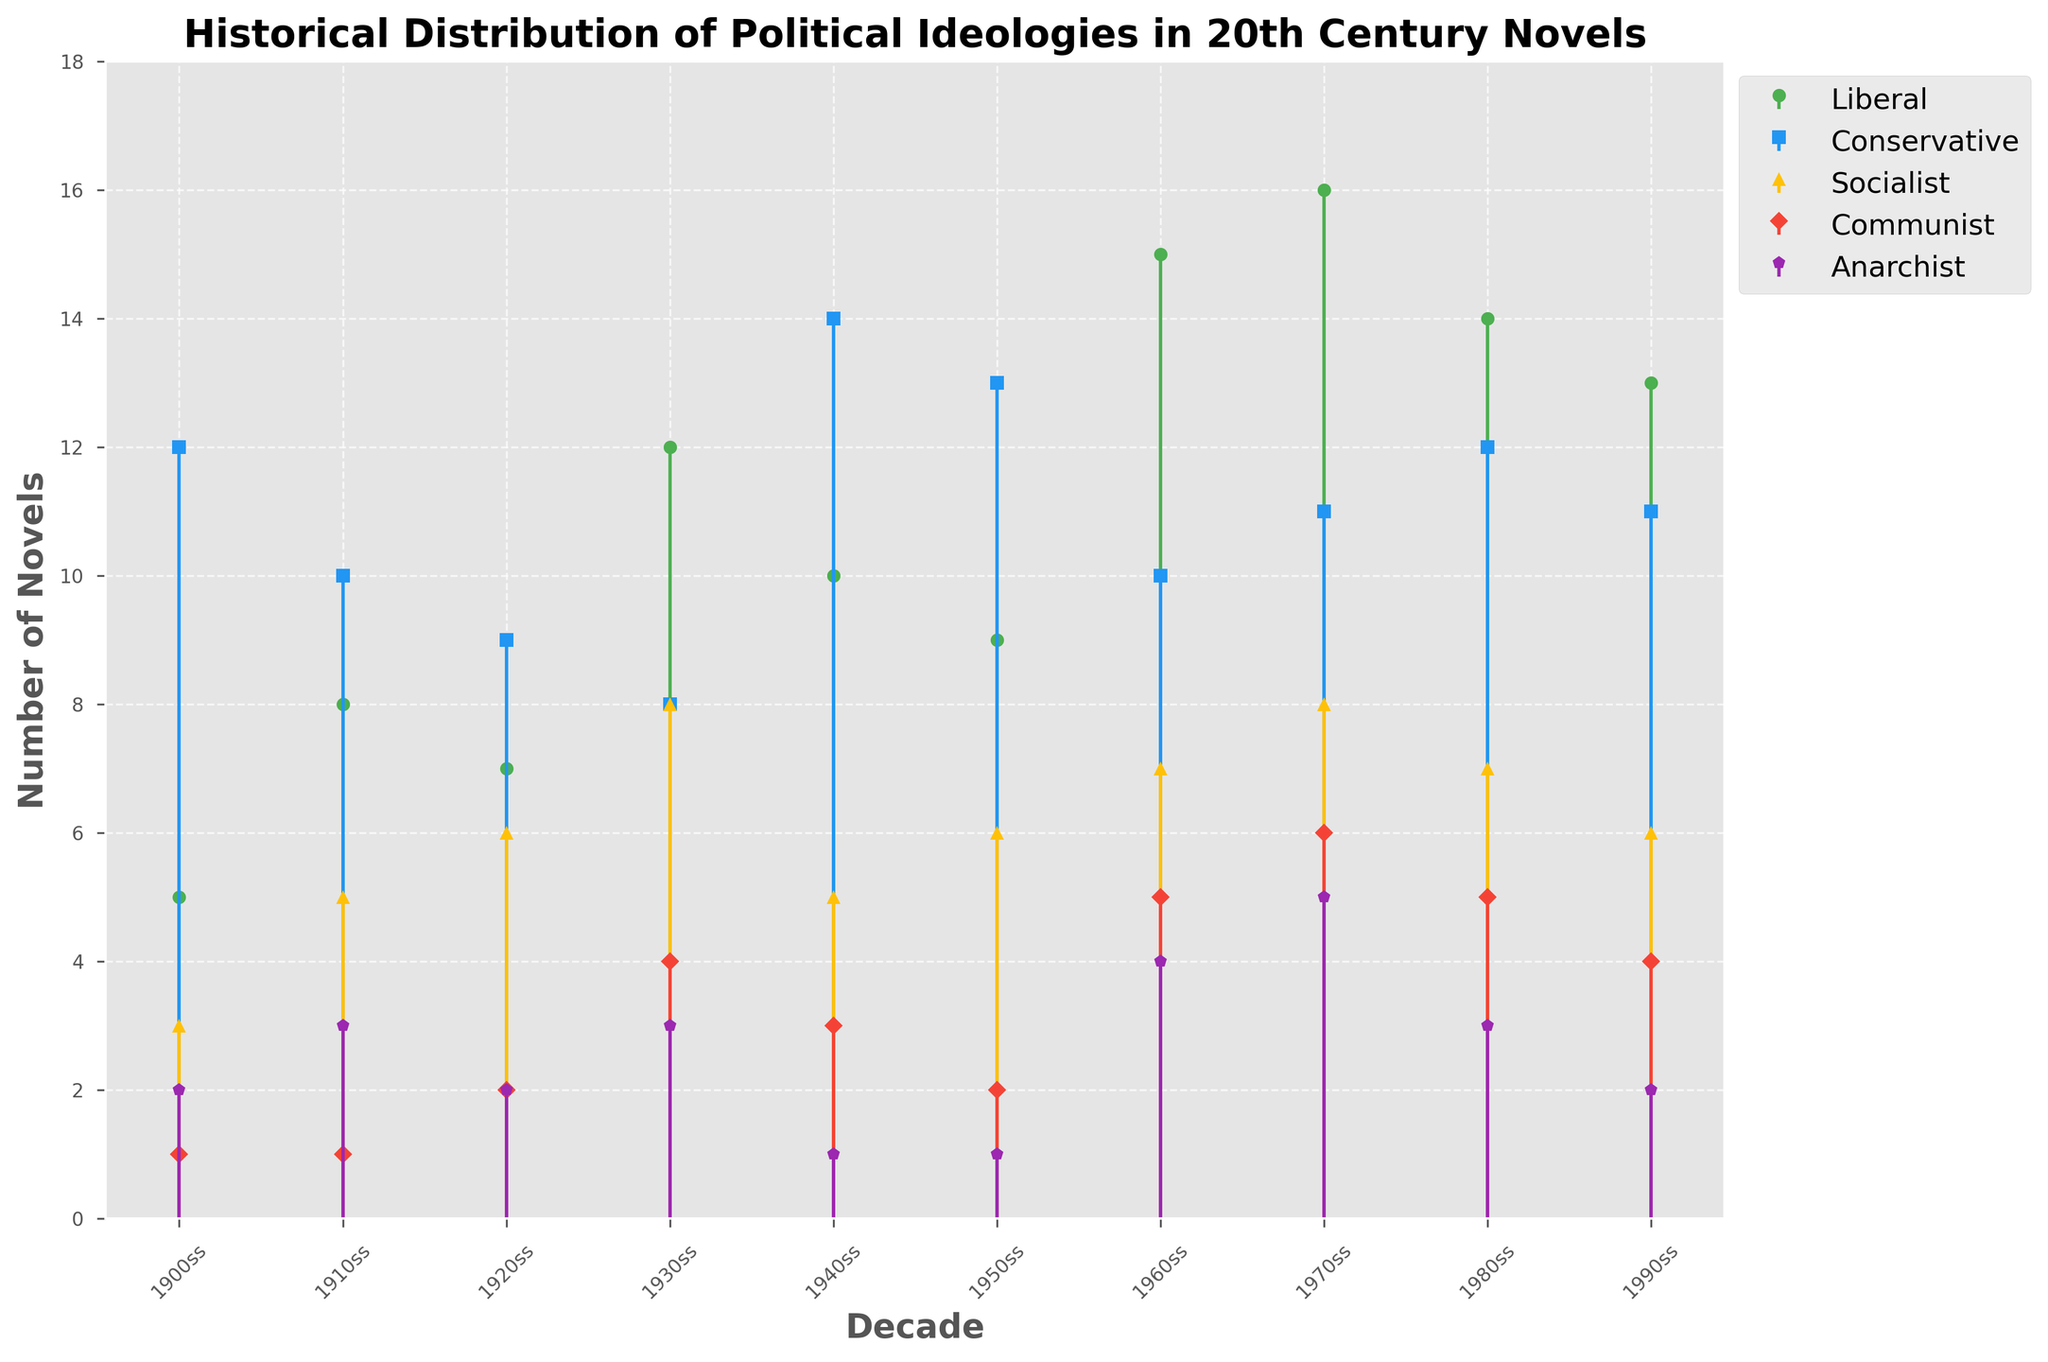What is the title of the figure? The title is usually placed at the top of the figure. In this case, it is written clearly above the plot.
Answer: Historical Distribution of Political Ideologies in 20th Century Novels How many political ideologies are represented in the plot? The legend to the right of the plot lists the political ideologies represented. There are five ideologies mentioned.
Answer: Five During which decade do Socialist novels peak in number? By examining the stem plot, look for the highest point in the line representing Socialist novels. This occurs in the 1930s.
Answer: 1930s Which decade had the highest number of novels with Conservative ideologies? Find the decade where the stem plot line for Conservative ideologies reaches its highest point. This is most prominent in the 1940s.
Answer: 1940s What is the combined number of Liberal and Conservative novels in the 1970s? Identify the values for Liberal and Conservative novels in the 1970s and add them together: 16 (Liberal) + 11 (Conservative) = 27.
Answer: 27 Which ideology had the lowest representation in the 1980s, and what was the number? Looking at the stem plot for the 1980s, identify the ideology with the smallest stem. The smallest stem corresponds to Anarchist ideology, which had 3 novels.
Answer: Anarchist, 3 Was there an increase or decrease in the number of Communist novels between the 1940s and 1950s, and by how much? Check the number of Communist novels in the 1940s and 1950s and calculate the difference: 3 (1940s) - 2 (1950s) = 1. There was a decrease.
Answer: Decrease, 1 How does the number of Anarchist novels in the 1960s compare to the 1990s? Find the values for Anarchist novels in both decades and compare: 4 (1960s) - 2 (1990s) = 2. The 1960s had more Anarchist novels by 2.
Answer: 2 more in the 1960s In which decade did the number of Liberal novels reach its highest point? Look for the highest stem for Liberal novels over the different decades. This occurs in the 1970s.
Answer: 1970s What is the average number of novels with Socialist ideologies in the first five decades (1900s-1940s)? Sum the number of Socialist novels from the first five decades: 3 (1900s) + 5 (1910s) + 6 (1920s) + 8 (1930s) + 5 (1940s) = 27. Then divide by 5: 27 / 5 = 5.4.
Answer: 5.4 